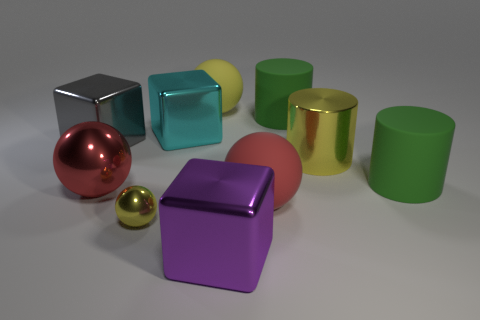The cylinder that is the same material as the gray block is what size?
Your response must be concise. Large. There is a big purple shiny object; are there any metal objects behind it?
Keep it short and to the point. Yes. Does the tiny yellow thing have the same shape as the big purple shiny object?
Provide a short and direct response. No. There is a green matte cylinder behind the green matte cylinder that is on the right side of the yellow thing on the right side of the big yellow ball; how big is it?
Your answer should be very brief. Large. What is the large yellow cylinder made of?
Keep it short and to the point. Metal. What size is the other metal object that is the same color as the small shiny thing?
Give a very brief answer. Large. There is a red matte object; is its shape the same as the green object that is in front of the big gray thing?
Keep it short and to the point. No. There is a red object to the right of the big ball that is behind the large green cylinder that is in front of the cyan metal object; what is it made of?
Ensure brevity in your answer.  Rubber. What number of cyan balls are there?
Your answer should be compact. 0. How many red objects are either matte balls or big spheres?
Your answer should be compact. 2. 